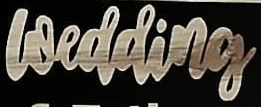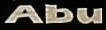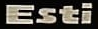Transcribe the words shown in these images in order, separated by a semicolon. wedding; Abu; Esti 